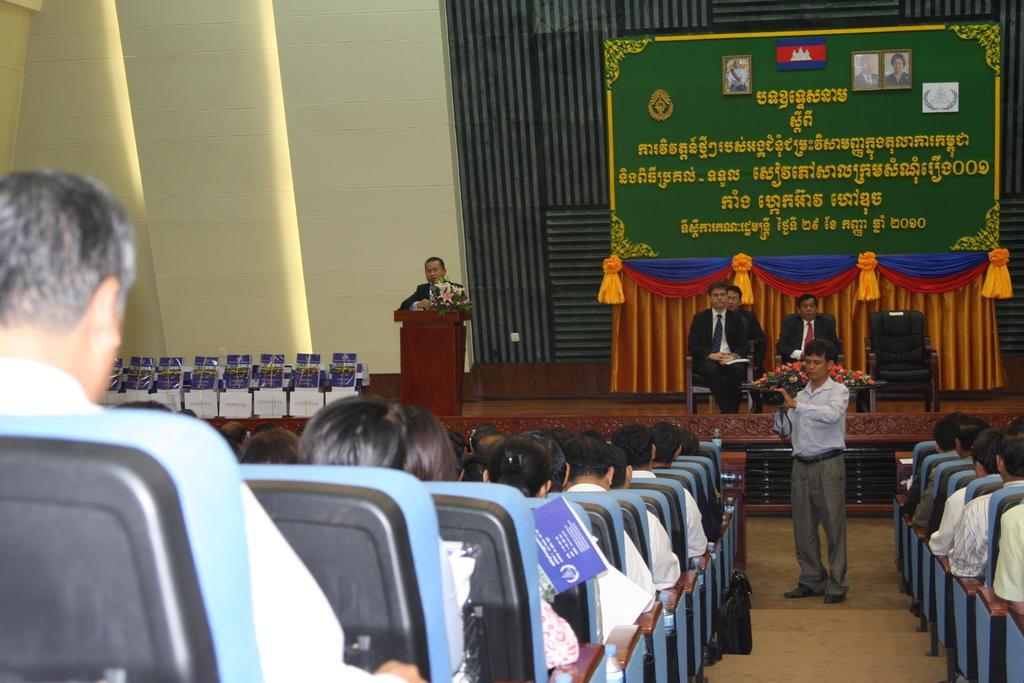Describe this image in one or two sentences. In this image we can see a group of people are sitting on the chair, here a person is standing on the ground, and holding a camera in the hands, here is the staircase, here a person is standing near the podium, here are the persons sitting, and wearing the suit, here is the curtain, here is the wall. 